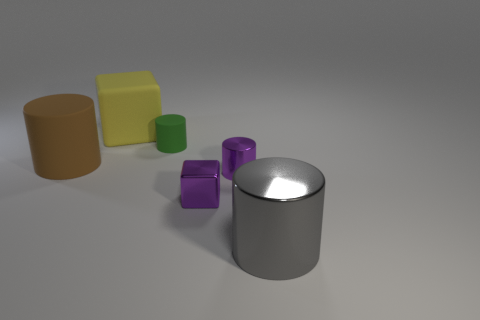There is a big object that is both left of the gray metallic object and in front of the green matte cylinder; what is its color?
Provide a succinct answer. Brown. There is a small purple block; are there any metallic things behind it?
Keep it short and to the point. Yes. There is a small thing right of the tiny metal cube; what number of tiny metal things are in front of it?
Give a very brief answer. 1. What is the size of the gray thing that is the same material as the tiny purple cube?
Provide a short and direct response. Large. The green cylinder is what size?
Your response must be concise. Small. Is the gray cylinder made of the same material as the small purple cylinder?
Offer a terse response. Yes. How many balls are tiny gray things or yellow objects?
Your answer should be compact. 0. What color is the small matte cylinder that is behind the matte object that is in front of the tiny green object?
Provide a succinct answer. Green. What number of brown things are in front of the tiny cylinder that is in front of the big cylinder that is behind the gray metallic object?
Make the answer very short. 0. Do the matte object that is in front of the green cylinder and the large rubber object on the right side of the large brown object have the same shape?
Ensure brevity in your answer.  No. 